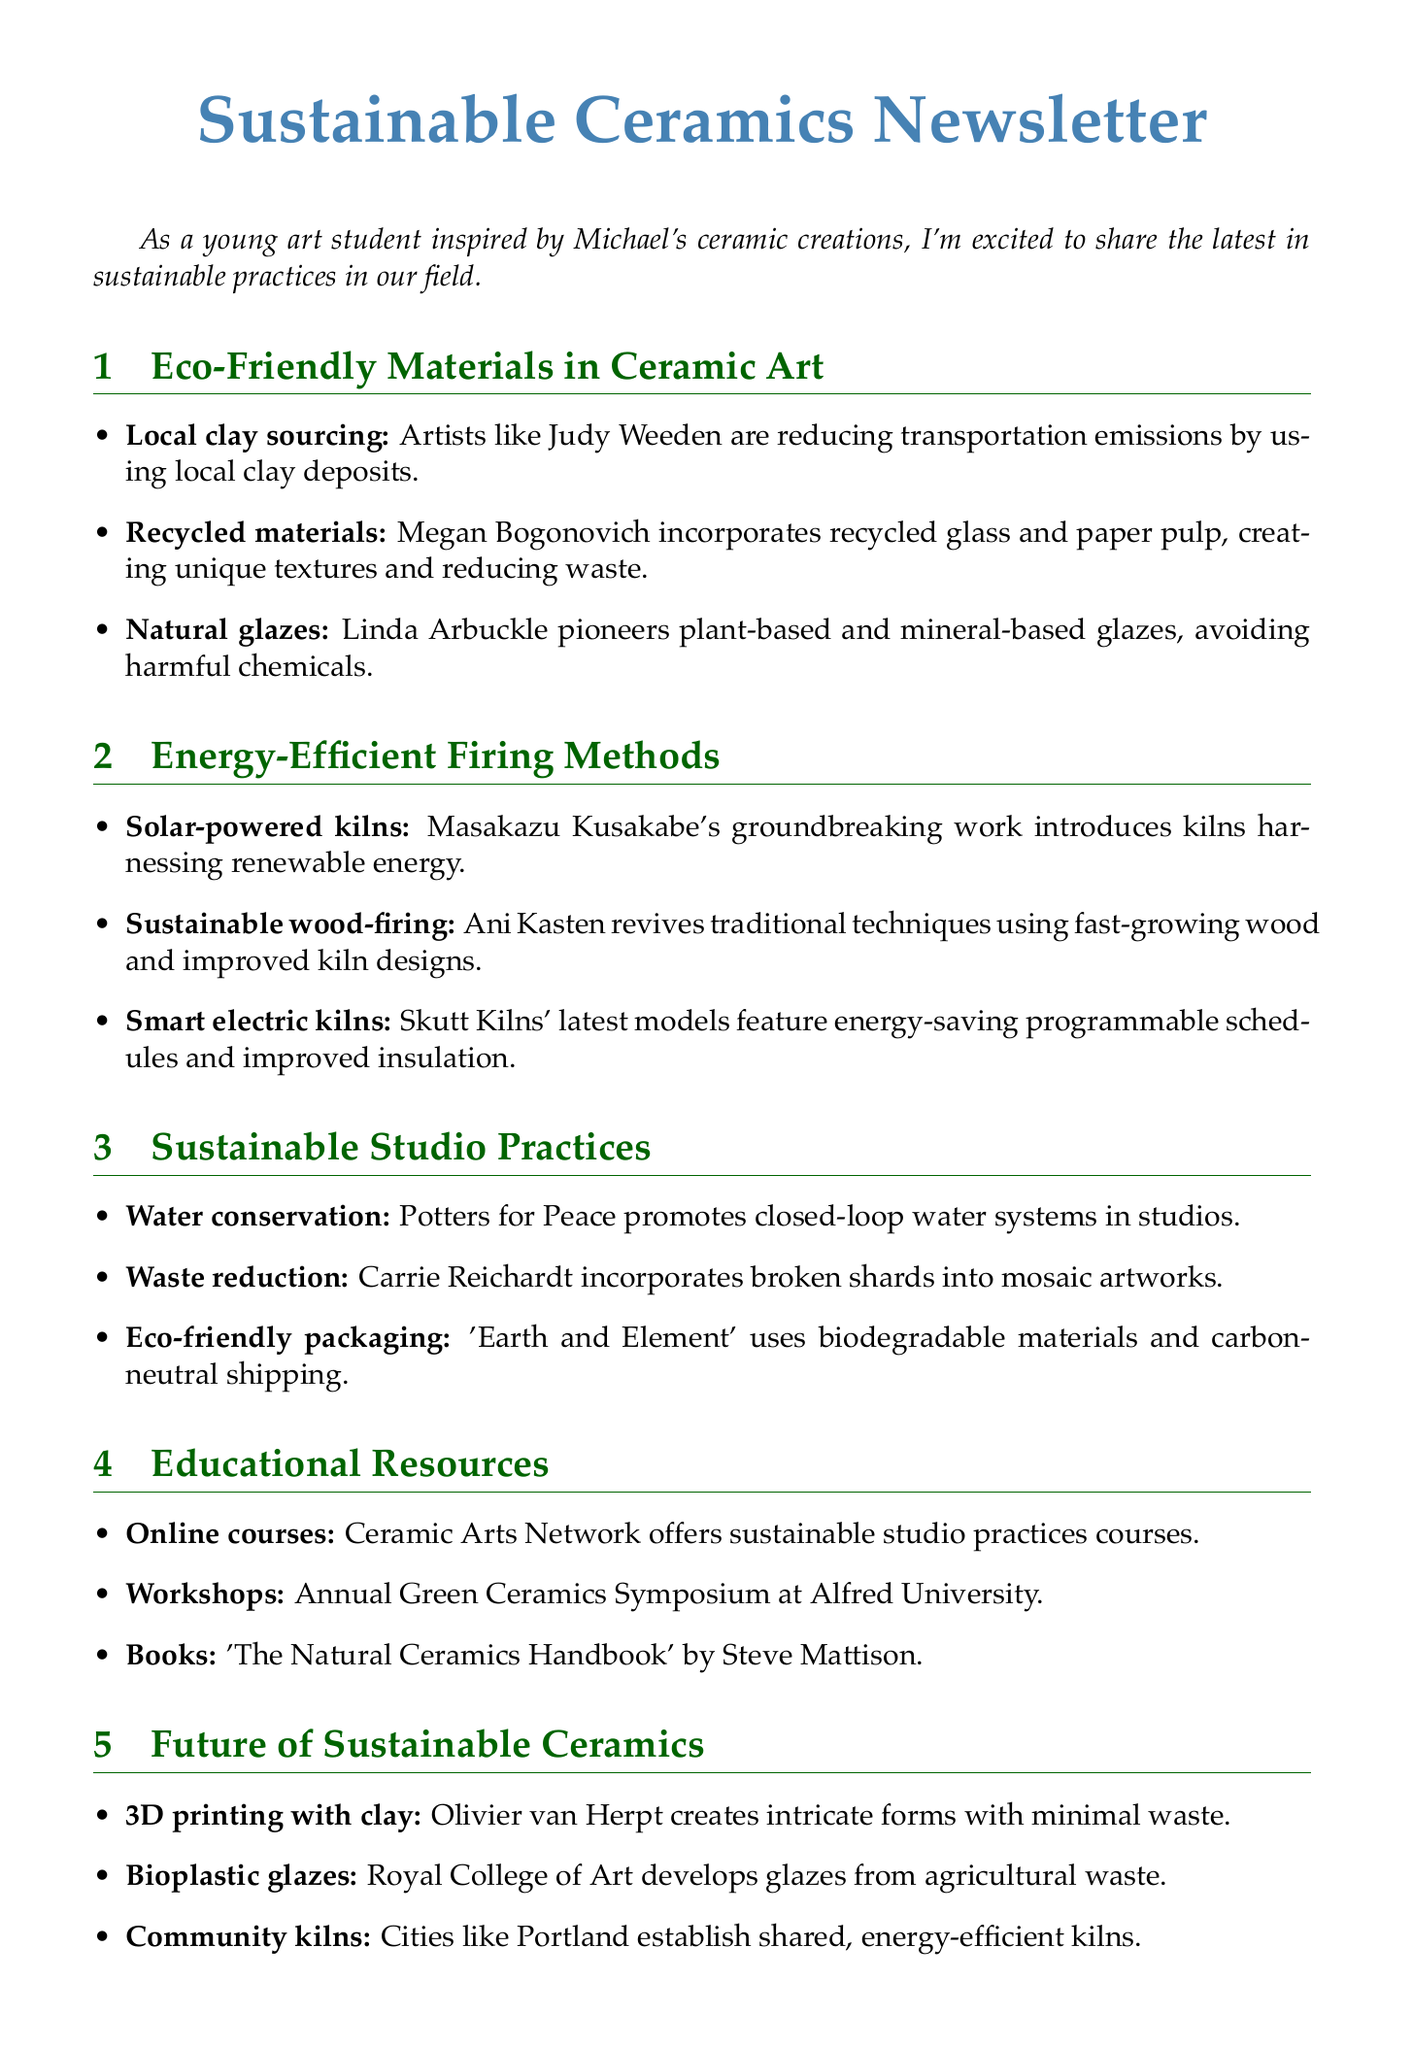What is the title of the newsletter? The title provides the main theme of the document, which is mentioned at the top.
Answer: Sustainable Ceramics Newsletter Which artist is known for using local clay deposits? This information is found under the Eco-Friendly Materials section, specifically mentioning an artist's sustainable practice.
Answer: Judy Weeden What innovative material does Megan Bogonovich incorporate into her ceramic pieces? The document specifies this material in the context of recycled content and its unique texture.
Answer: Recycled glass and paper pulp What type of kilns does Masakazu Kusakabe work with? This detail is included in the Energy-Efficient Firing Methods section, highlighting the type of energy used in kilns.
Answer: Solar-powered What organization promotes closed-loop water systems in studios? The document provides the name of this organization in the context of sustainable studio practices.
Answer: Potters for Peace Which annual event offers workshops on sustainable ceramics? The document mentions this recurring event aimed at education in sustainable practices.
Answer: Green Ceramics Symposium What book is recommended for learning about eco-friendly techniques? The suggestion for a book is in the Educational Resources section, referring specifically to useful literature.
Answer: The Natural Ceramics Handbook Which emerging trend involves 3D printing technology? This trend is mentioned in the Future of Sustainable Ceramics section, indicating new methods being explored.
Answer: 3D printing with clay What type of glazes is being developed from agricultural waste? The document notes this trend under the Future of Sustainable Ceramics, revealing innovative research.
Answer: Bioplastic glazes 